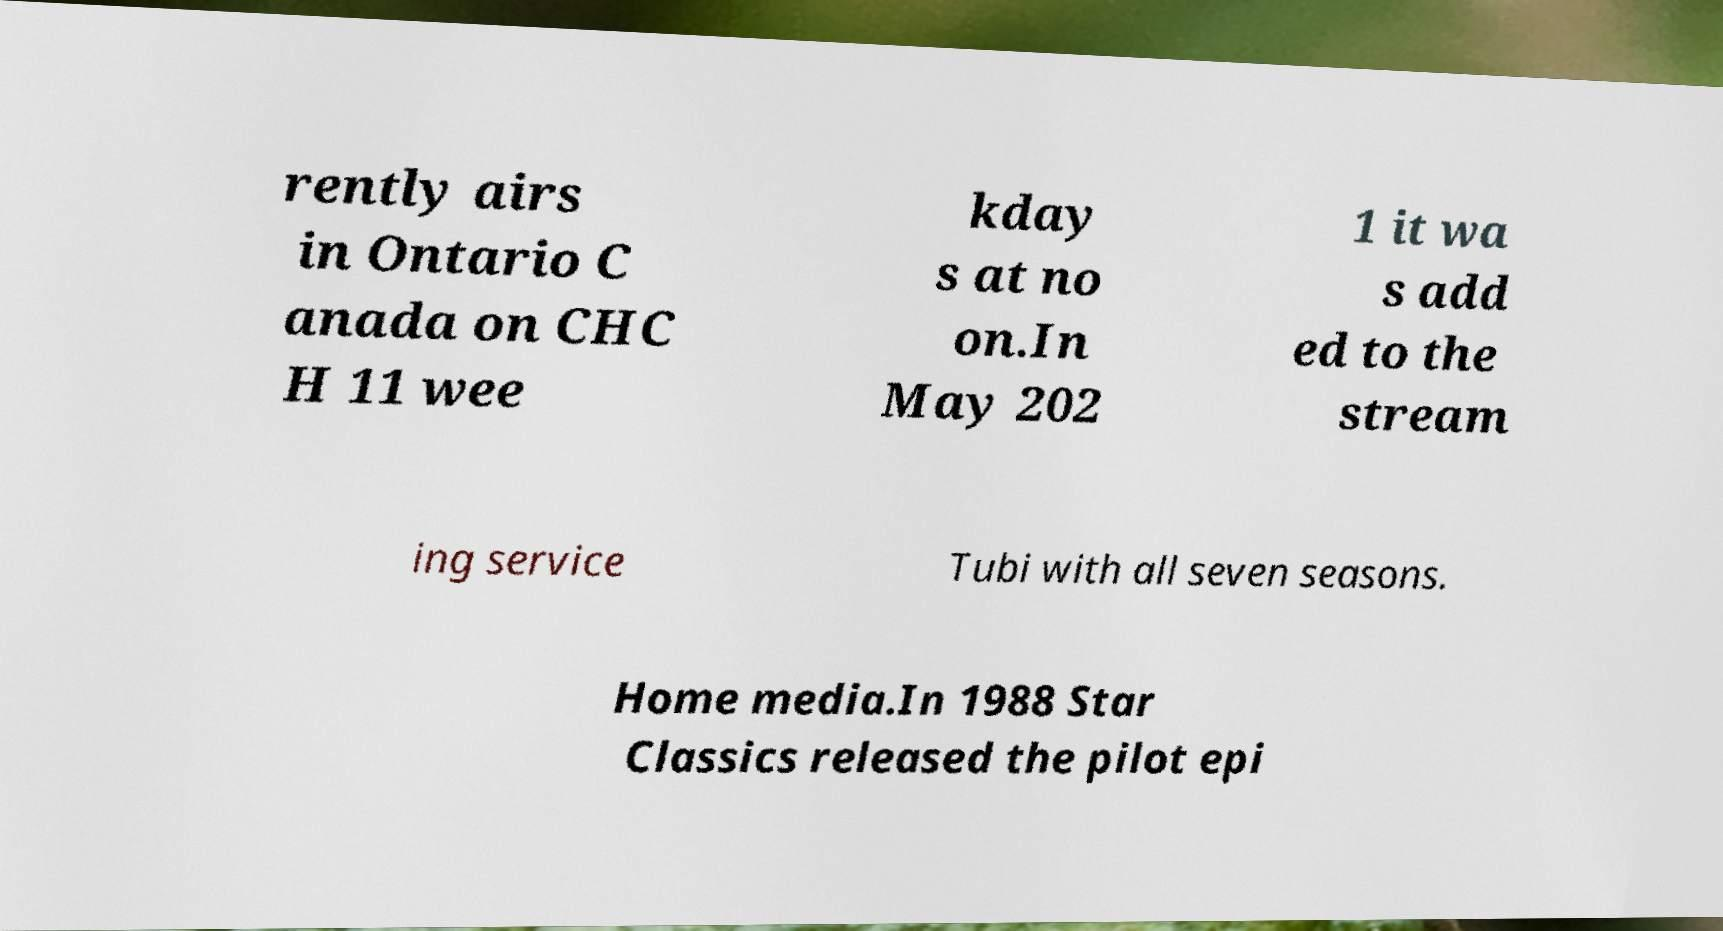There's text embedded in this image that I need extracted. Can you transcribe it verbatim? rently airs in Ontario C anada on CHC H 11 wee kday s at no on.In May 202 1 it wa s add ed to the stream ing service Tubi with all seven seasons. Home media.In 1988 Star Classics released the pilot epi 